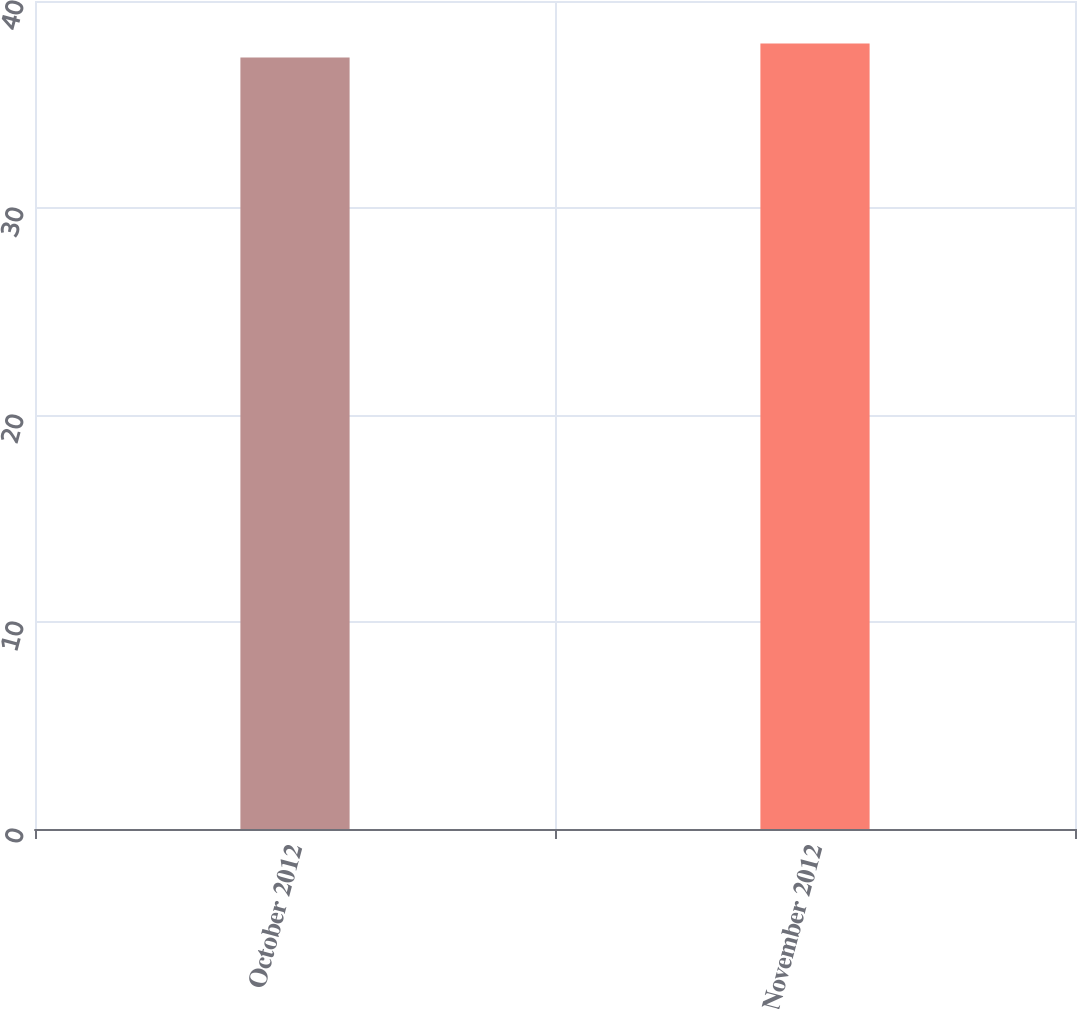Convert chart. <chart><loc_0><loc_0><loc_500><loc_500><bar_chart><fcel>October 2012<fcel>November 2012<nl><fcel>37.27<fcel>37.95<nl></chart> 